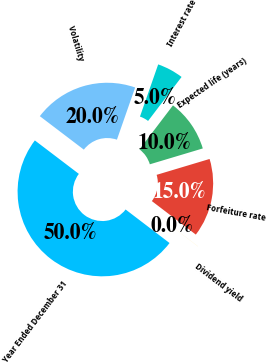Convert chart. <chart><loc_0><loc_0><loc_500><loc_500><pie_chart><fcel>Year Ended December 31<fcel>Volatility<fcel>Interest rate<fcel>Expected life (years)<fcel>Forfeiture rate<fcel>Dividend yield<nl><fcel>49.97%<fcel>20.0%<fcel>5.01%<fcel>10.01%<fcel>15.0%<fcel>0.01%<nl></chart> 